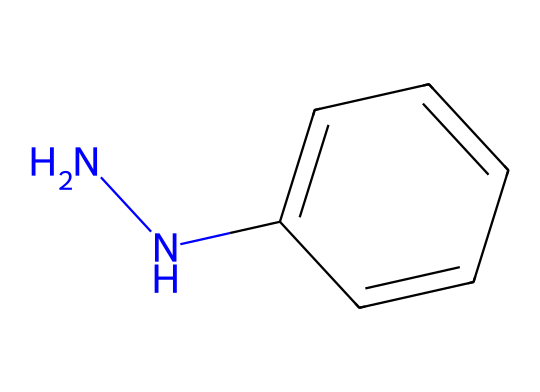What is the molecular formula of phenylhydrazine? To determine the molecular formula, count the constituent atoms from the SMILES representation. There are 6 carbon atoms (from the phenyl group), 8 hydrogen atoms, and 2 nitrogen atoms, leading to the formula C6H8N2.
Answer: C6H8N2 How many nitrogen atoms are present in phenylhydrazine? The SMILES representation includes "N" twice, indicating there are two nitrogen atoms in the structure.
Answer: 2 What type of chemical bond connects the nitrogen to the carbon in phenylhydrazine? The nitrogen atoms are connected to carbon atoms via single covalent bonds as seen in the linear arrangement of the SMILES string.
Answer: single bond What functional groups are present in phenylhydrazine? The structure clearly shows the presence of a hydrazine group (–N-N–) connected to an aromatic phenyl group.
Answer: hydrazine and phenyl How many rings are present in the structure of phenylhydrazine? The SMILES indicates a linear structure that does not form any cyclic or ring structure, resulting in zero rings.
Answer: 0 Which part of the molecule contributes to its reactivity as a reducing agent? The presence of the hydrazine functional group (N-N) is crucial for its reactivity as a reducing agent due to its ability to donate electrons.
Answer: hydrazine group Is phenylhydrazine an aromatic compound? Yes, the presence of the phenyl group (C1=CC=CC=C1) indicates that phenylhydrazine has an aromatic structure, allowing for resonance stability.
Answer: yes 